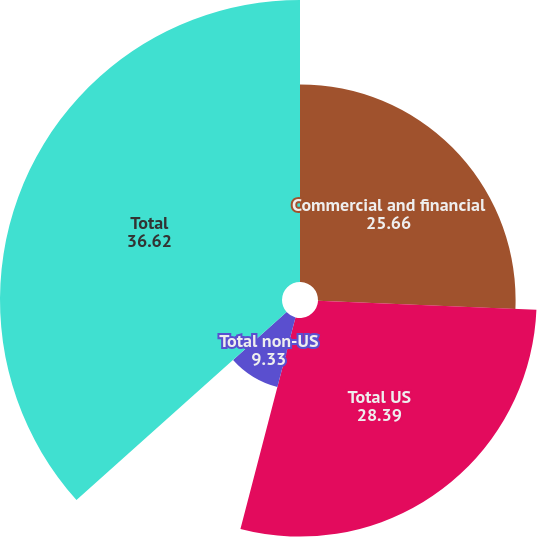Convert chart to OTSL. <chart><loc_0><loc_0><loc_500><loc_500><pie_chart><fcel>Commercial and financial<fcel>Total US<fcel>Total non-US<fcel>Total<nl><fcel>25.66%<fcel>28.39%<fcel>9.33%<fcel>36.62%<nl></chart> 